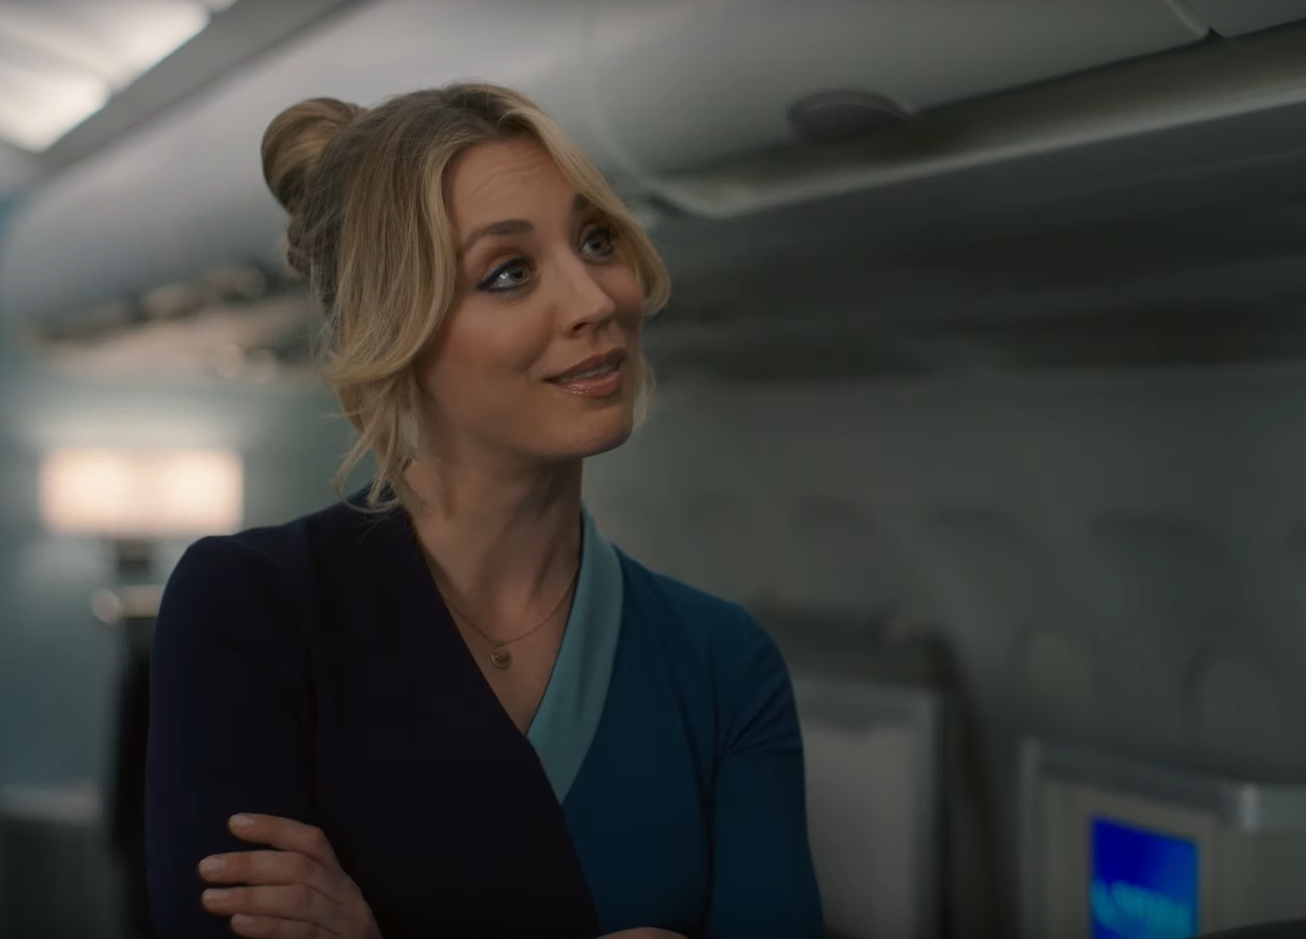Can you infer what moment is being captured here? The moment captured seems to depict a lighthearted interaction, likely between the flight attendant and another individual out of view. She seems to be mid-conversation, her expression suggests an anecdote or a moment of camaraderie is being shared. There's a strong sense of engagement and attentiveness in her stance, which indicates that this could be a scene highlighting the personable service and pleasant in-flight experience provided by the cabin crew. 